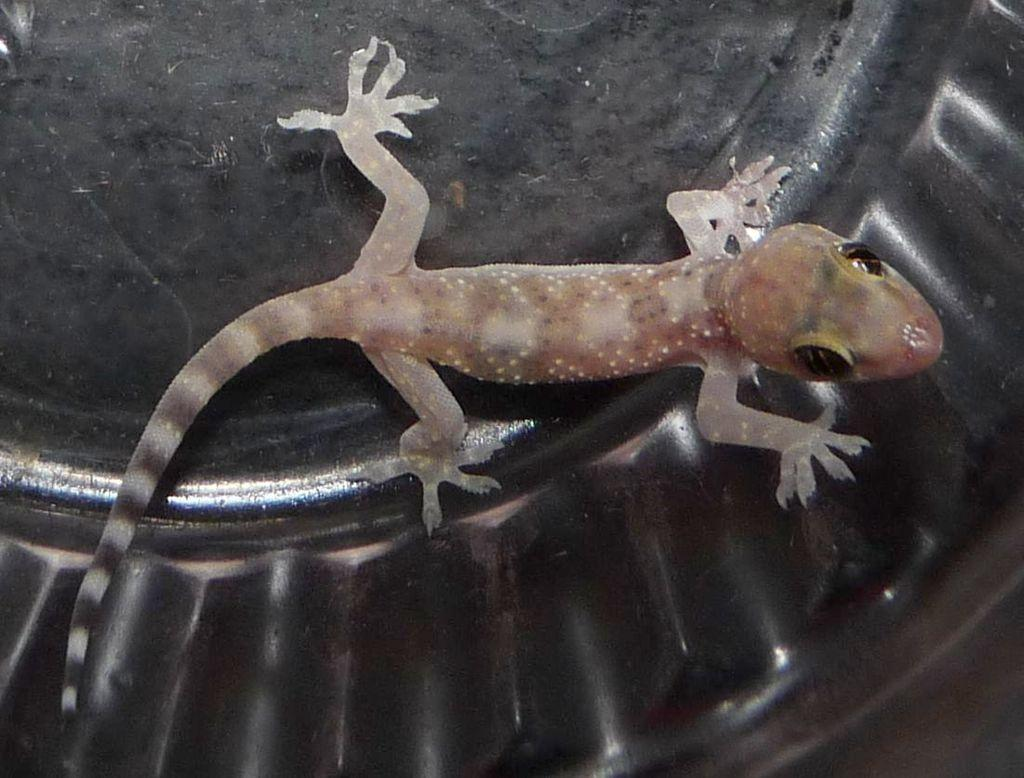What type of animal is present in the image? There is a lizard in the image. Where is the lizard located in the image? The lizard is on an object. What type of knowledge can be gained from the receipt in the image? There is no receipt present in the image, so no knowledge can be gained from it. 